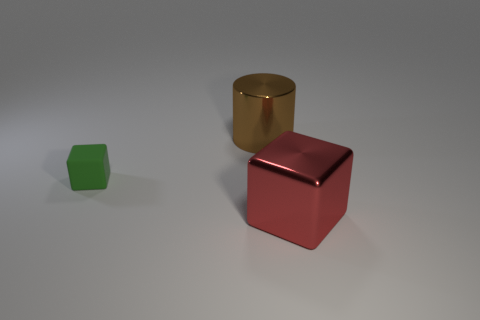Add 3 yellow rubber cylinders. How many objects exist? 6 Subtract all cylinders. How many objects are left? 2 Subtract 0 blue balls. How many objects are left? 3 Subtract all large brown objects. Subtract all tiny green matte cubes. How many objects are left? 1 Add 3 large metal cubes. How many large metal cubes are left? 4 Add 3 large cylinders. How many large cylinders exist? 4 